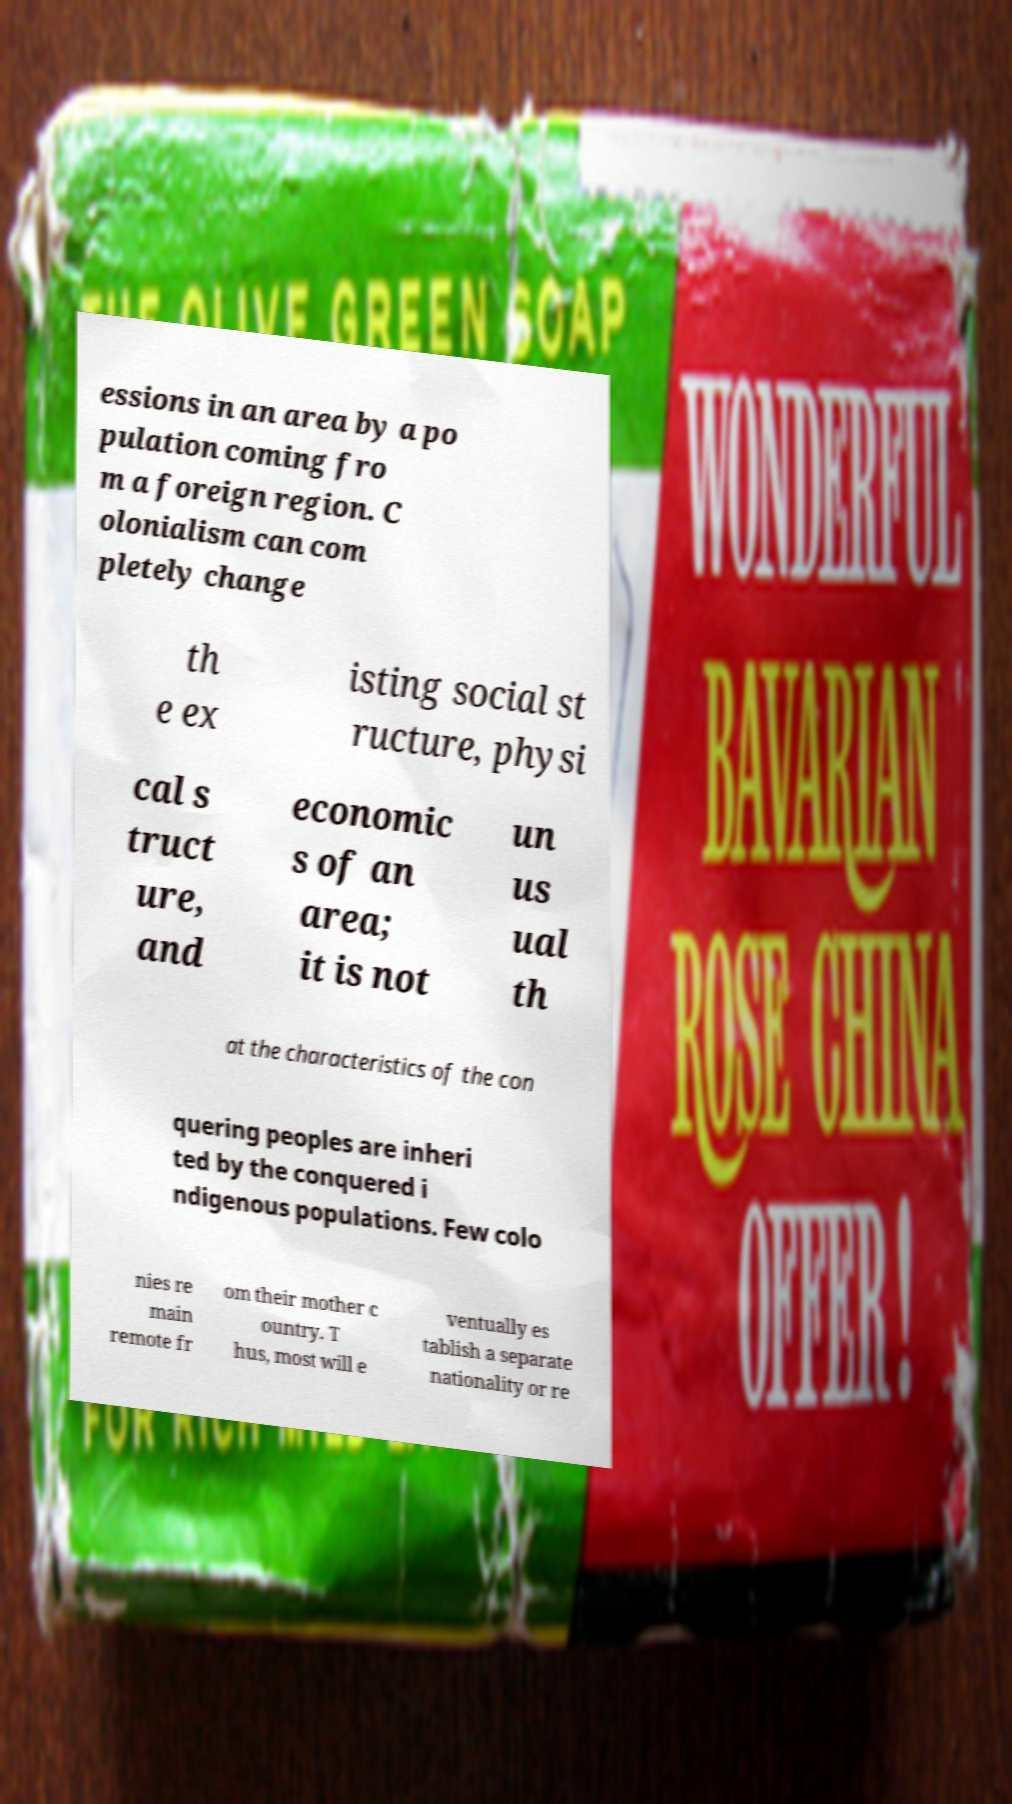Can you accurately transcribe the text from the provided image for me? essions in an area by a po pulation coming fro m a foreign region. C olonialism can com pletely change th e ex isting social st ructure, physi cal s truct ure, and economic s of an area; it is not un us ual th at the characteristics of the con quering peoples are inheri ted by the conquered i ndigenous populations. Few colo nies re main remote fr om their mother c ountry. T hus, most will e ventually es tablish a separate nationality or re 